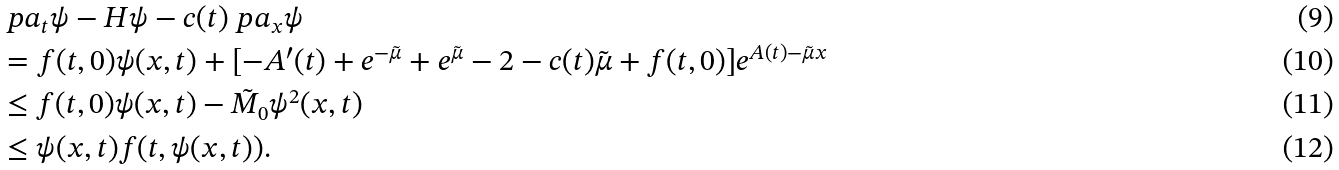<formula> <loc_0><loc_0><loc_500><loc_500>& \ p a _ { t } \psi - H \psi - c ( t ) \ p a _ { x } \psi \\ & = f ( t , 0 ) \psi ( x , t ) + [ - A ^ { \prime } ( t ) + e ^ { - \tilde { \mu } } + e ^ { \tilde { \mu } } - 2 - c ( t ) \tilde { \mu } + f ( t , 0 ) ] e ^ { A ( t ) - \tilde { \mu } x } \\ & \leq f ( t , 0 ) \psi ( x , t ) - \tilde { M } _ { 0 } \psi ^ { 2 } ( x , t ) \\ & \leq \psi ( x , t ) f ( t , \psi ( x , t ) ) .</formula> 